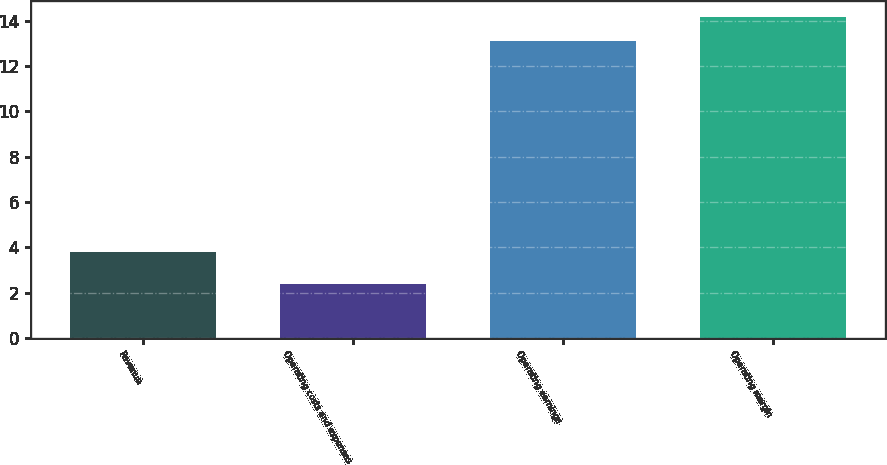Convert chart to OTSL. <chart><loc_0><loc_0><loc_500><loc_500><bar_chart><fcel>Revenue<fcel>Operating costs and expenses<fcel>Operating earnings<fcel>Operating margin<nl><fcel>3.8<fcel>2.4<fcel>13.1<fcel>14.17<nl></chart> 